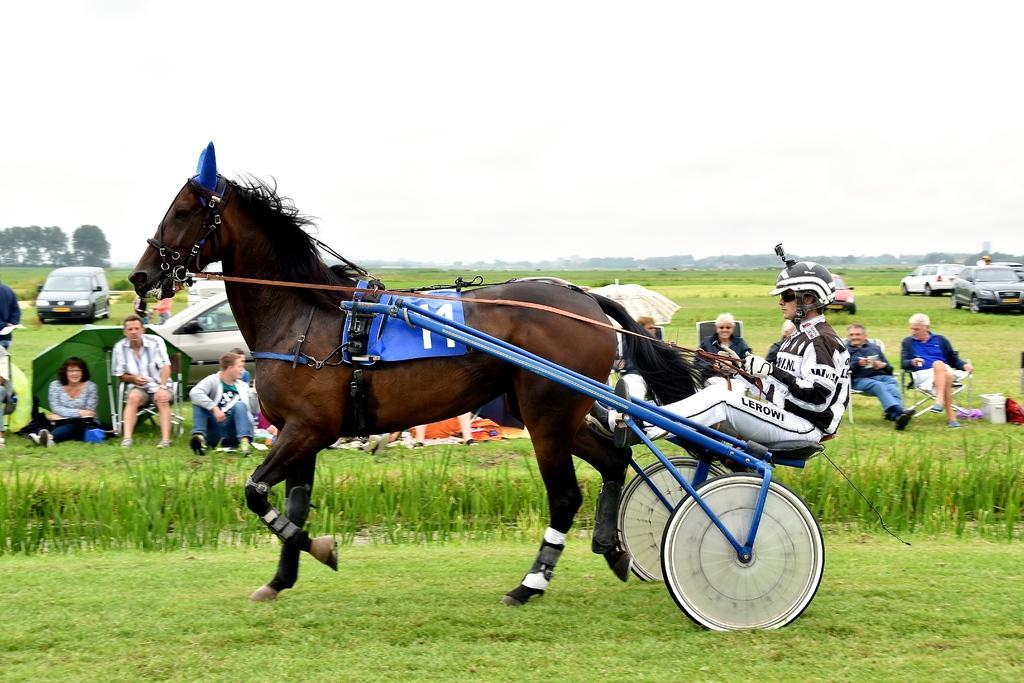How would you summarize this image in a sentence or two? In this image I see a horse and I see that this cart is tied to horse and I see a person who is sitting on this cart and I see the green grass. In the background I see number of people who are sitting and I see few cars and I see the trees and I see the sky. 